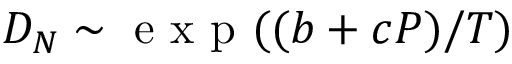<formula> <loc_0><loc_0><loc_500><loc_500>D _ { N } \sim e x p ( ( b + c P ) / T )</formula> 